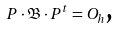<formula> <loc_0><loc_0><loc_500><loc_500>P \cdot \mathfrak { B } \cdot P ^ { t } = O _ { h } \text {,}</formula> 